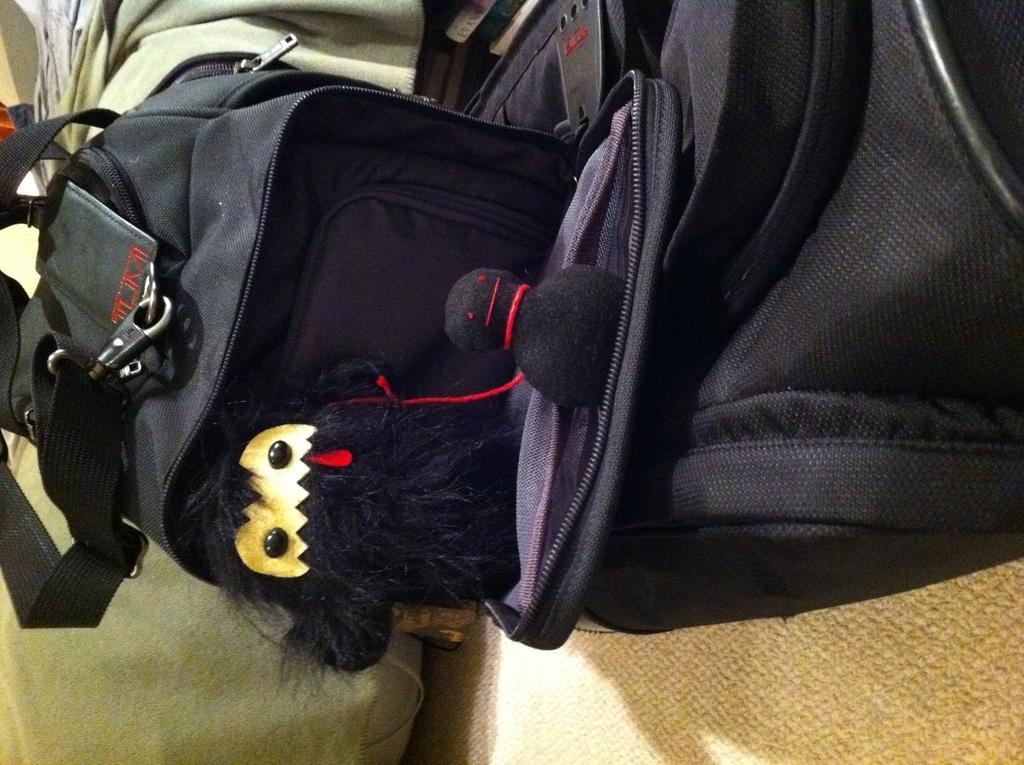Can you describe this image briefly? In this picture we can see a toy in the bag which is in black color. 